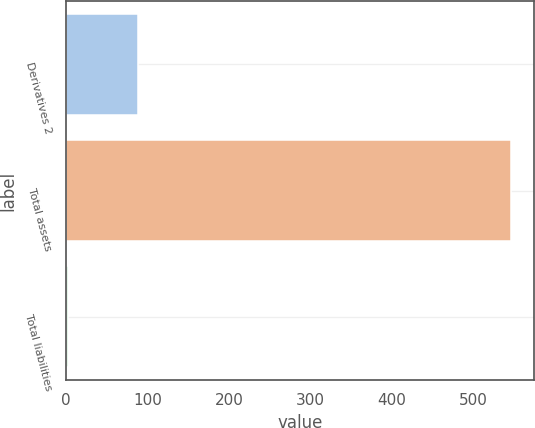Convert chart to OTSL. <chart><loc_0><loc_0><loc_500><loc_500><bar_chart><fcel>Derivatives 2<fcel>Total assets<fcel>Total liabilities<nl><fcel>88<fcel>547<fcel>2<nl></chart> 